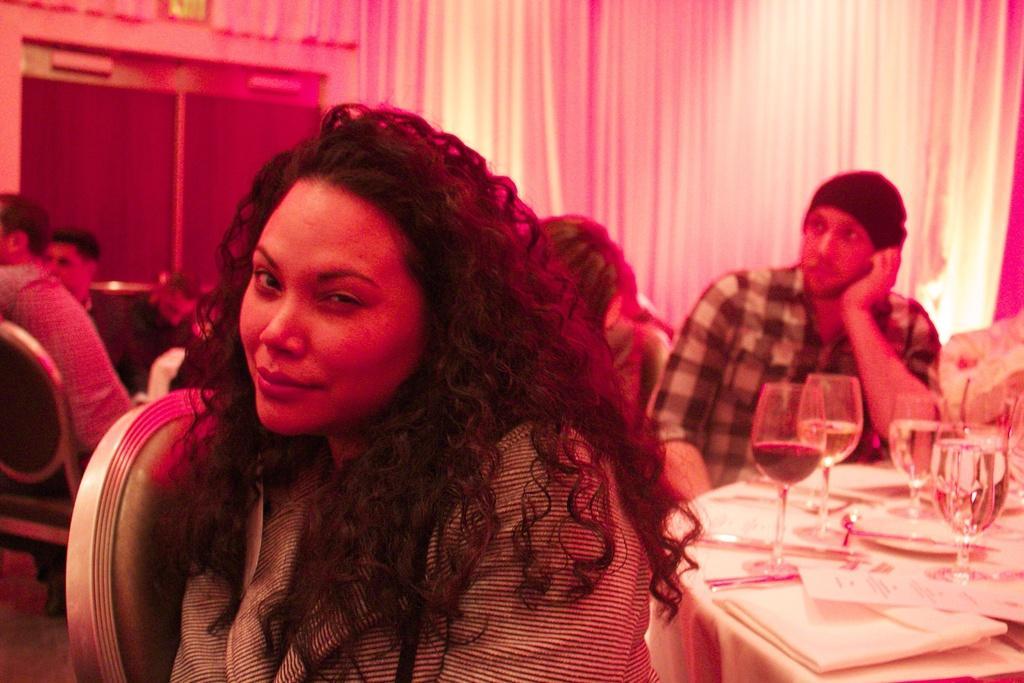Please provide a concise description of this image. In this image we can see a few people sitting on the chairs, there is a table, on the table, we can see the glasses and some other objects, in the background, we can see the curtains. 